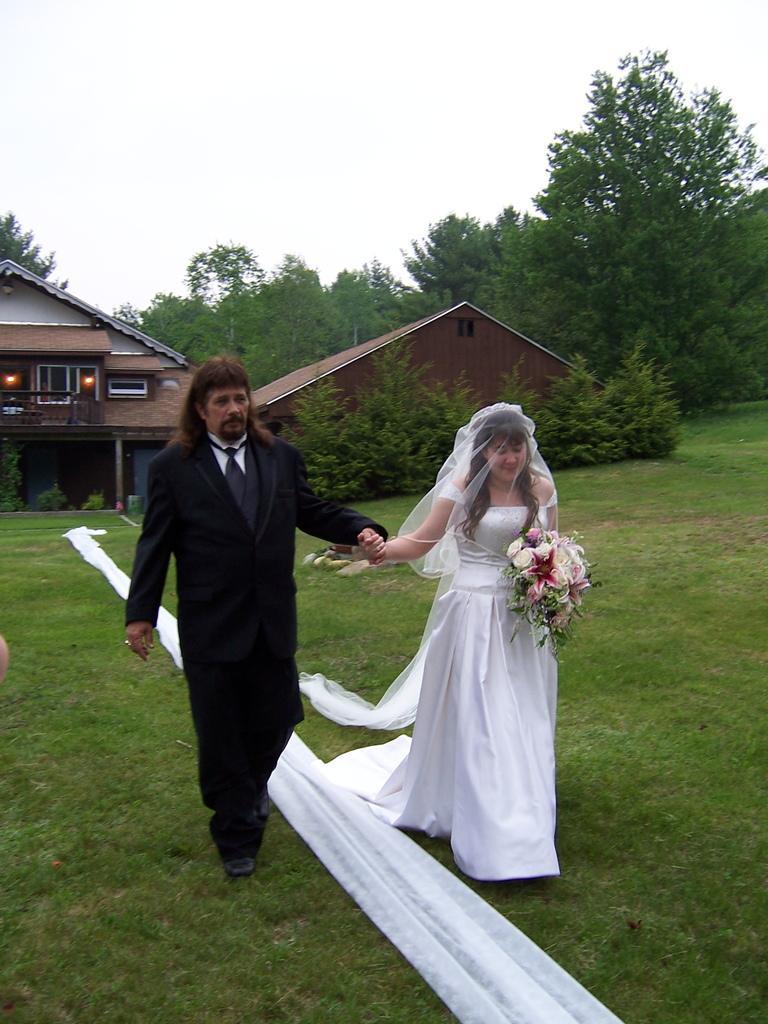In one or two sentences, can you explain what this image depicts? In this picture we can see a man and a woman walking on the ground where a woman is holding flowers with her hand and in the background we can see houses, trees, sky. 